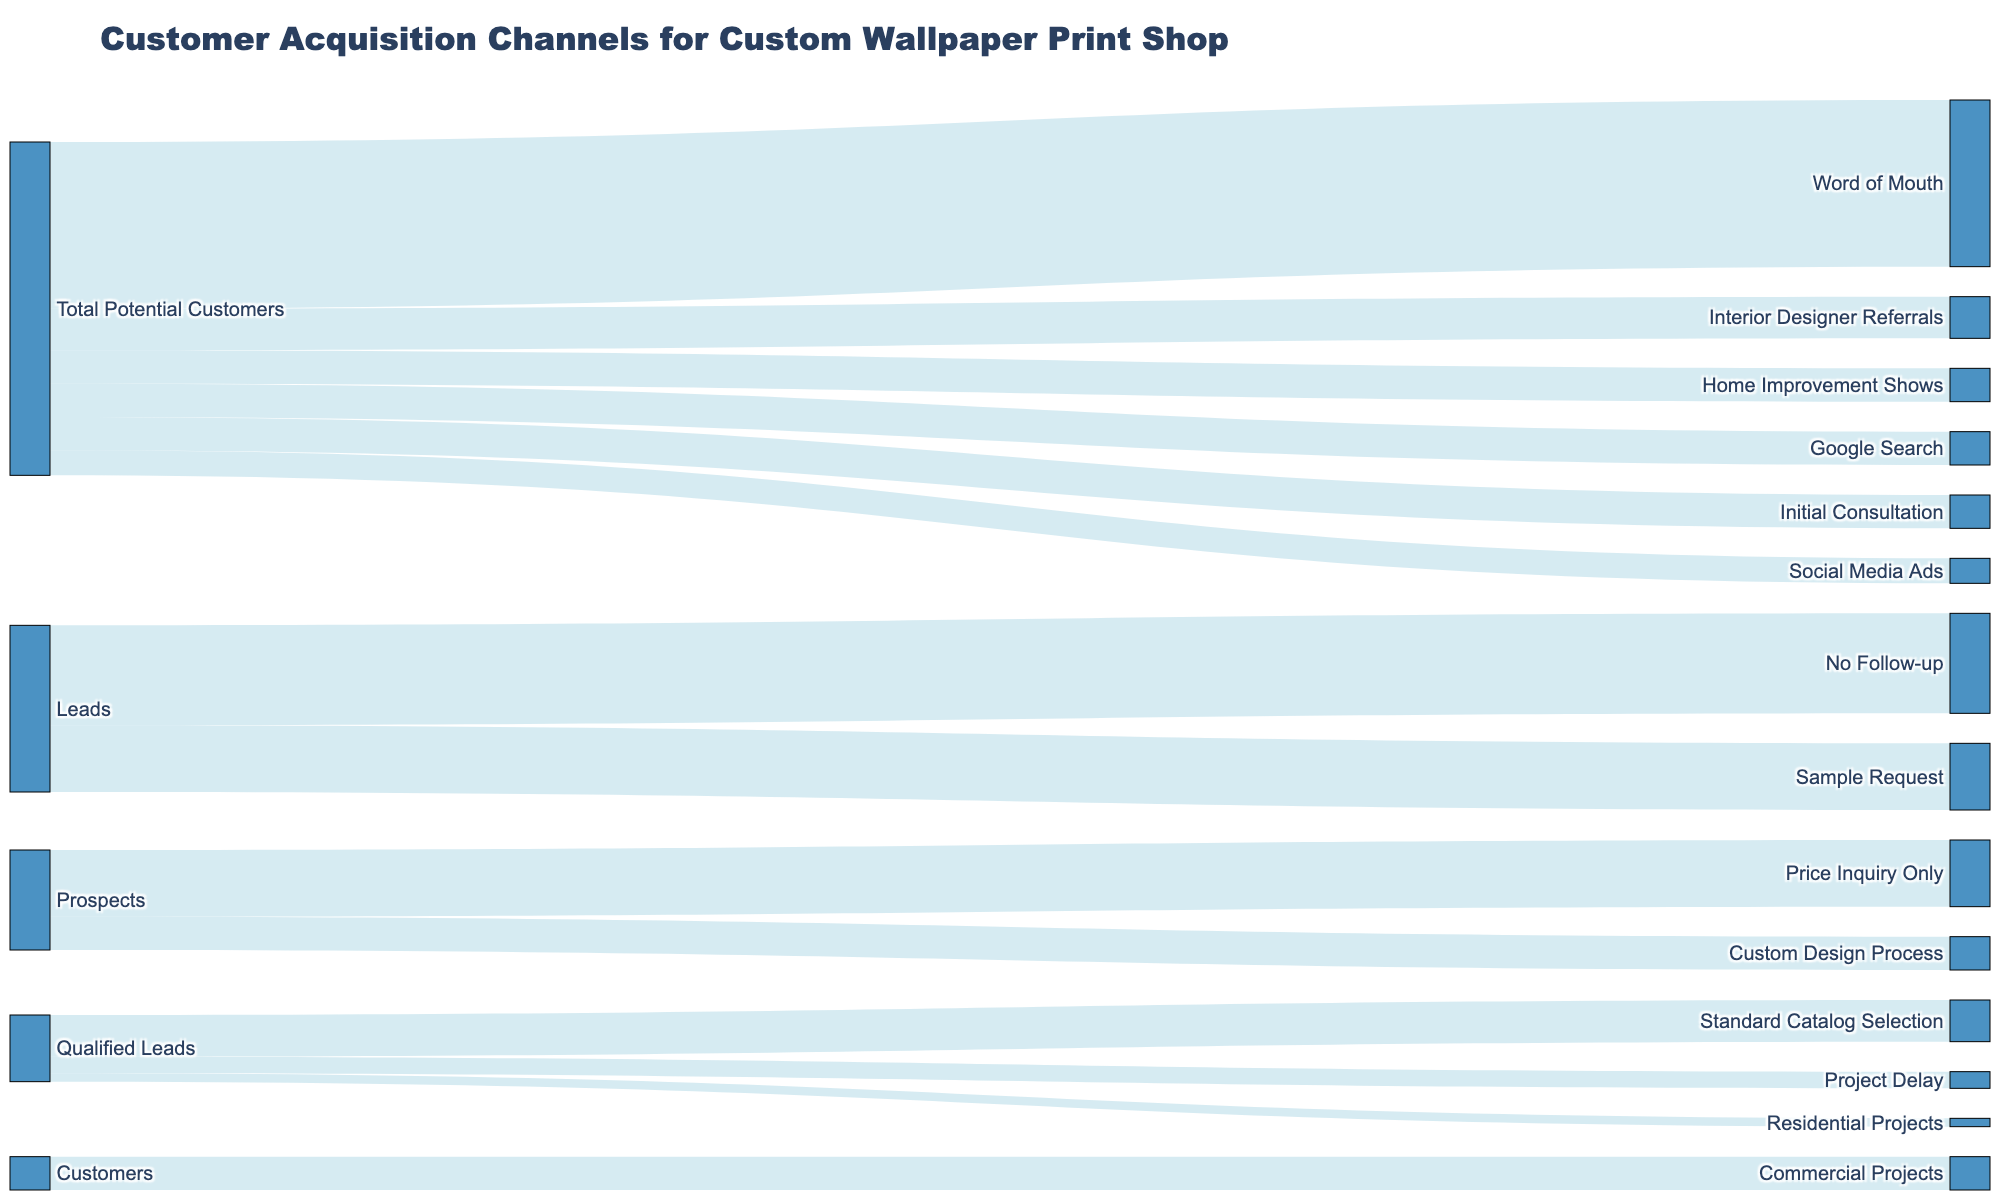What is the total number of potential customers? The total potential customers are represented by the "Total Potential Customers" node and the value next to it.
Answer: 1000 How many customers were acquired from Interior Designer Referrals? The link connecting "Total Potential Customers" to "Interior Designer Referrals" shows the number of leads from this channel.
Answer: 200 What is the total number of leads that resulted in initial consultations? The link from "Leads" to "Initial Consultation" represents this.
Answer: 600 How many potential customers were lost without any follow-up? The link from "Leads" to "No Follow-up" shows the number lost at this stage.
Answer: 400 What portion of prospects requested samples? The value at the link from "Prospects" to "Sample Request" indicates this number.
Answer: 400 How many qualified leads resulted in customers after the custom design process? The link from "Qualified Leads" to "Custom Design Process" shows the number of customers from this process.
Answer: 250 What is the total revenue generated from residential and commercial projects? Sum the values from "Customers" to "Residential Projects" and "Commercial Projects". 200 (Residential) + 150 (Commercial) = 350.
Answer: 350 Which acquisition channel resulted in the highest number of leads? Compare the values of the links from "Total Potential Customers" to each channel.
Answer: Word of Mouth (250) How many qualified leads were lost due to project delays? The link from "Qualified Leads" to "Project Delay" shows the number of losses.
Answer: 50 What is the number of customers choosing standard catalog selections over custom design processes? Compare the values of the links from "Qualified Leads" to "Standard Catalog Selection" and "Custom Design Process".
Answer: Standard Catalog Selection: 100, Custom Design Process: 250 